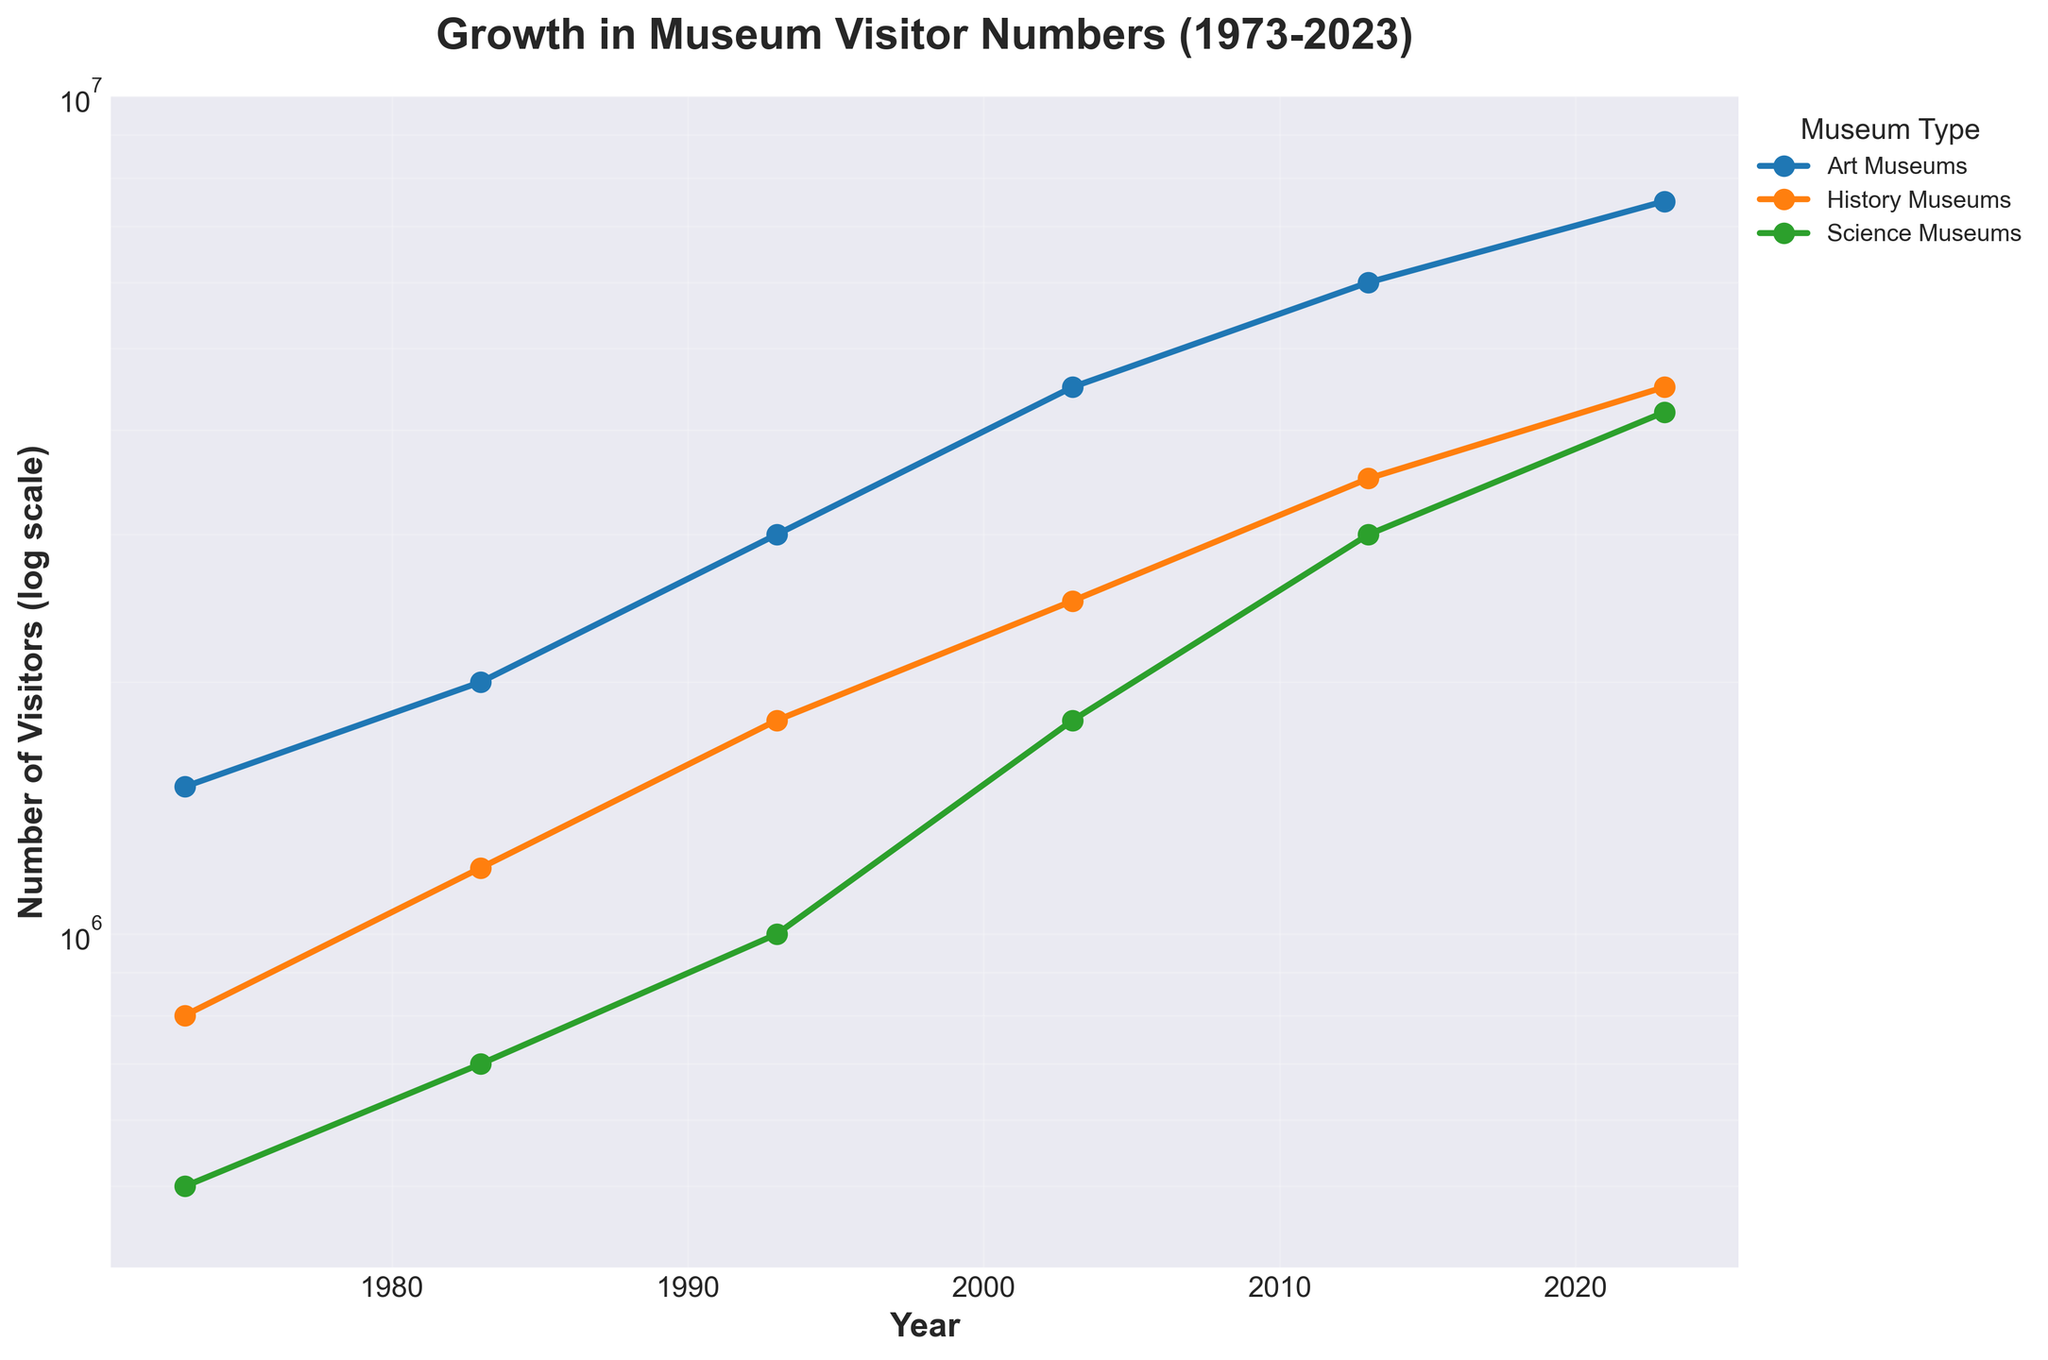what is the title of the plot? Look at the top of the plot where the bolded text is located.
Answer: Growth in Museum Visitor Numbers (1973-2023) What ranges do the y-axis cover? Observe the y-axis labels to understand the span of visitor numbers covered.
Answer: 400,000 to 10,000,000 How many unique museum types are plotted? Identify the unique labels in the legend or inspect the different line markers.
Answer: 3 Which museum type had the highest number of visitors in 2023? Examine the final data points on the right side of the plot and find the line at the top.
Answer: Art Museums What is the difference in visitor numbers between Art Museums and Science Museums in 2023? Look at the data points for both Art Museums and Science Museums in 2023, then subtract the number of visitors for Science Museums from that of Art Museums.
Answer: 3,300,000 In which year did the visitors to History Museums exceed those of Science Museums for the first time? Compare the lines for History Museums and Science Museums, starting from the left of the plot and moving right, to find the first intersection point.
Answer: 1983 What can you observe about the general trend in visitor numbers for all museum types? Check how the lines representing different museum types change from left to right, assessing if they rise, fall, or remain stable over time.
Answer: Generally rising trends Which museum type shows the greatest rate of increase in visitor numbers over the 50 years? Observe the slope of each line over the entire period; the steeper the line, the greater the rate of increase.
Answer: Art Museums How are the years distributed on the x-axis? Look at the x-axis to understand the span and intervals of the years plotted.
Answer: Evenly spaced between 1973 and 2023 If a museum had 2,500,000 visitors in a particular year, could you determine which museum type and year it corresponds to? Locate the 2,500,000 mark on the log-scaled y-axis and trace horizontally to find intersections with the lines, then trace vertically down to the corresponding year.
Answer: History Museums in 2003 